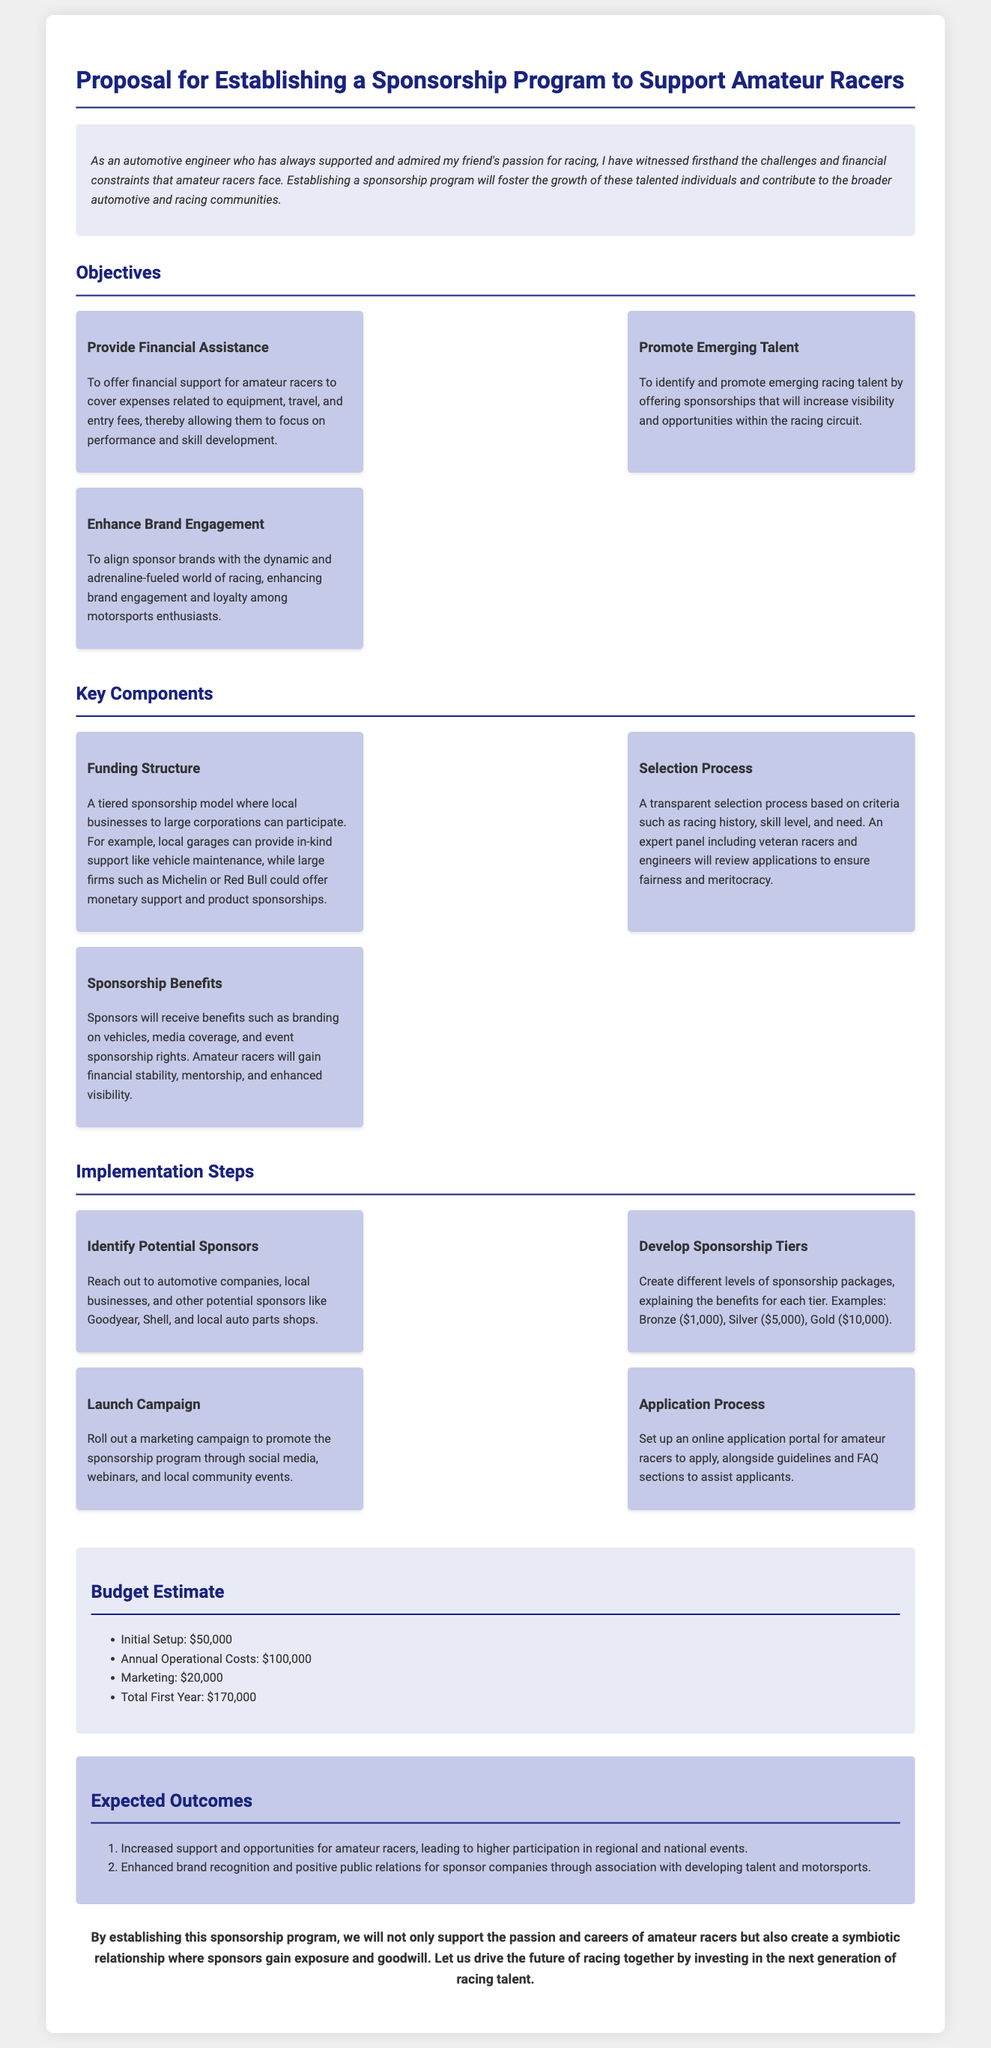What are the key objectives of the sponsorship program? The key objectives include providing financial assistance, promoting emerging talent, and enhancing brand engagement.
Answer: Financial assistance, promoting emerging talent, enhancing brand engagement What is the initial setup cost for the sponsorship program? The initial setup cost is explicitly mentioned in the budget estimate section of the document.
Answer: $50,000 What is the total first-year budget estimate? The total first-year budget is calculated by adding all expenses outlined in the budget estimate.
Answer: $170,000 How many steps are outlined in the implementation section? The implementation steps section lists specific steps involved in launching the sponsorship program.
Answer: Four Who will receive branding benefits according to the proposal? The sponsorship benefits state who will receive branding.
Answer: Sponsors What type of businesses are potential sponsors mentioned in the implementation steps? Potential sponsors include various types of companies, as listed in the document.
Answer: Automotive companies, local businesses What are the expected outcomes of the sponsorship program? The expected outcomes of the program are detailed in the outcomes section of the document.
Answer: Increased support and opportunities for amateur racers, enhanced brand recognition What is the selection process based on? The selection process is mentioned in the key components section, specifying the criteria used.
Answer: Racing history, skill level, and need What is the purpose of the sponsorship program? The introduction section provides the primary purpose of the sponsorship program.
Answer: Support amateur racers 